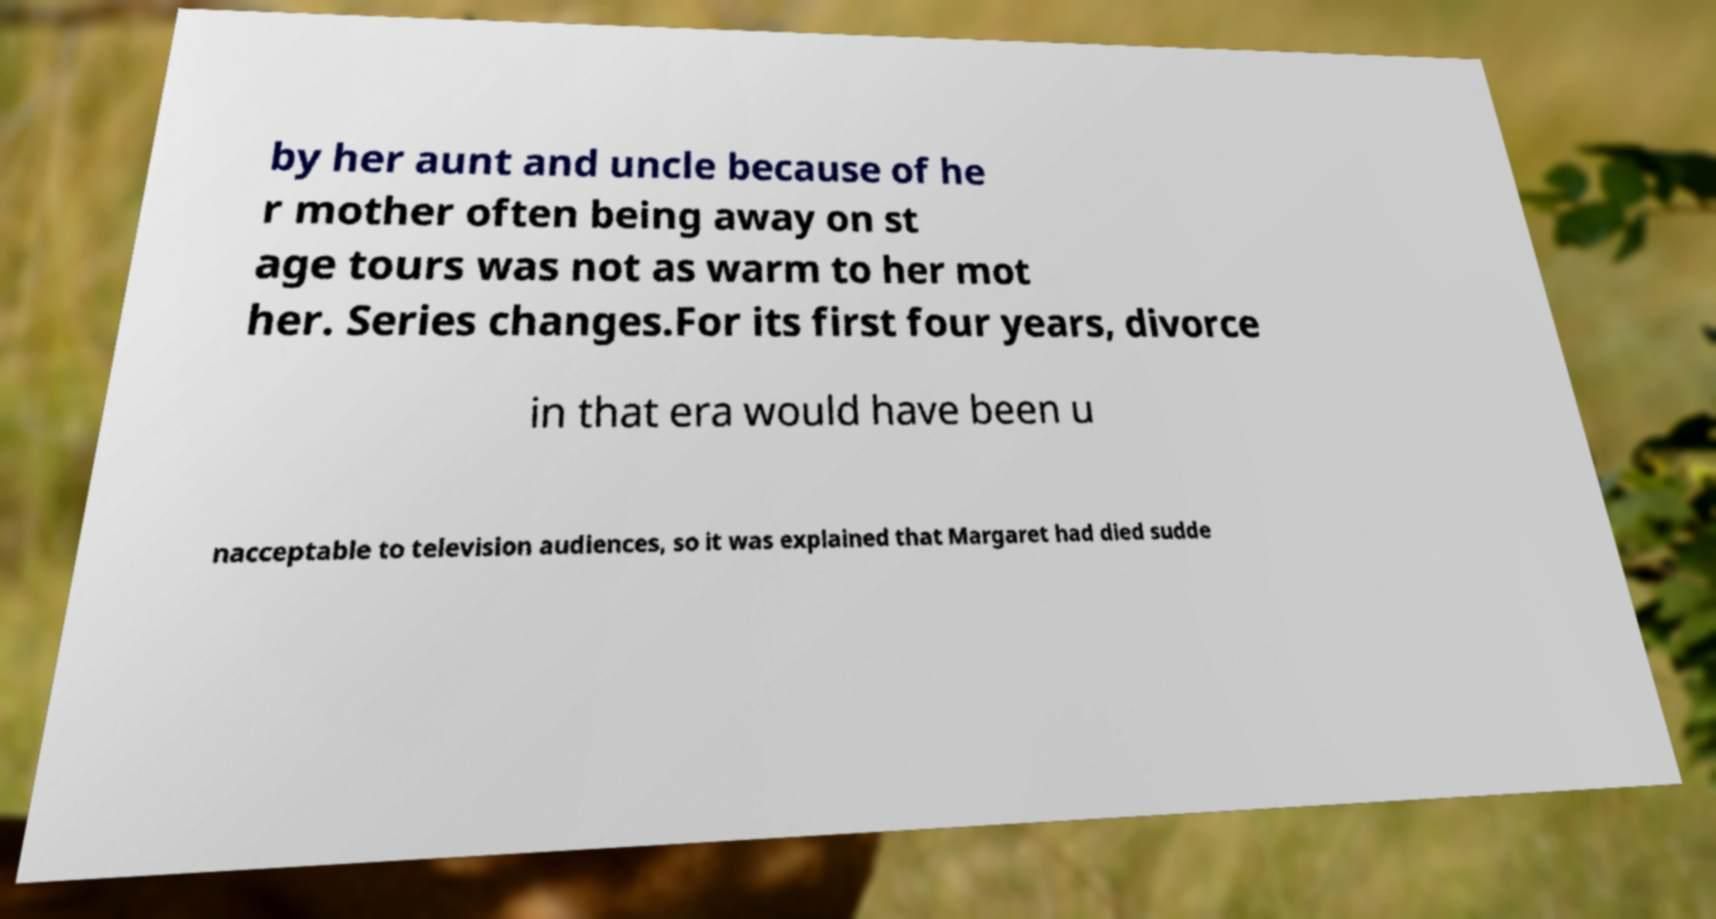Can you accurately transcribe the text from the provided image for me? by her aunt and uncle because of he r mother often being away on st age tours was not as warm to her mot her. Series changes.For its first four years, divorce in that era would have been u nacceptable to television audiences, so it was explained that Margaret had died sudde 